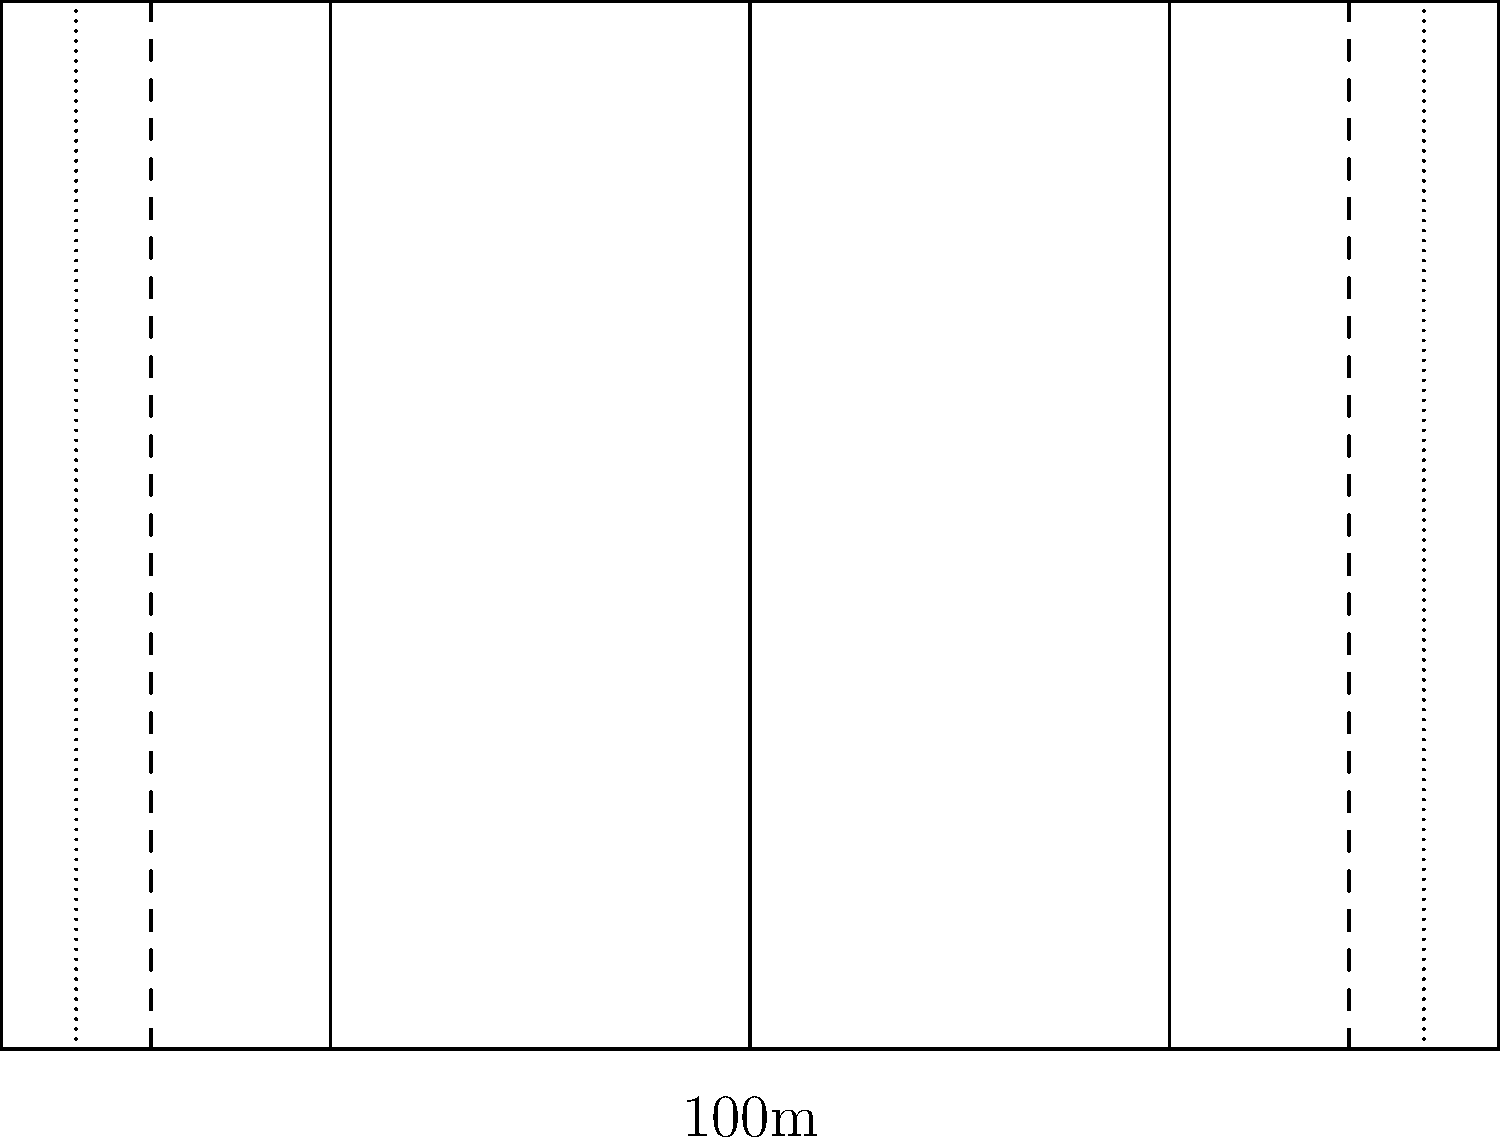As a rugby coach in Cairns, you're tasked with explaining the optimal field layout for a rugby pitch to your team. Based on the diagram, what is the total length of a rugby field, including the in-goal areas, and what is the significance of the 22-meter lines? To answer this question, let's break down the key elements of a rugby field layout:

1. Field dimensions:
   - The main playing area is 100 meters long and 70 meters wide.
   - There are two in-goal areas, each 10 meters deep, located at both ends of the field.

2. Total field length calculation:
   - Main playing area: 100 meters
   - Two in-goal areas: 2 × 10 meters = 20 meters
   - Total length: 100 + 20 = 120 meters

3. The 22-meter lines:
   - These lines are drawn 22 meters from each try line (the line between the main playing area and the in-goal area).
   - They serve several important purposes in the game:
     a) Restarts: If a team touches the ball down in their own in-goal area, play restarts with a 22-meter drop-out.
     b) Kicking to touch: If a player kicks the ball to touch (out of bounds) from within their own 22-meter area, the lineout is taken from where the ball crossed the touchline.
     c) Tactical significance: The 22-meter area is often used for strategic kicking and defensive positioning.

4. Other important markings:
   - Halfway line: Divides the field into two equal halves and is where kick-offs are taken.
   - 10-meter lines (dashed): Indicate the minimum distance the receiving team must be from a kick-off.
   - 5-meter lines (dotted): Used for positioning scrums and lineouts.
   - Center circle: Where kick-offs are taken from.

Understanding these dimensions and markings is crucial for players to position themselves correctly and for coaches to develop effective strategies based on field position.
Answer: 120 meters; 22-meter lines are used for restarts, kicking to touch, and tactical play. 